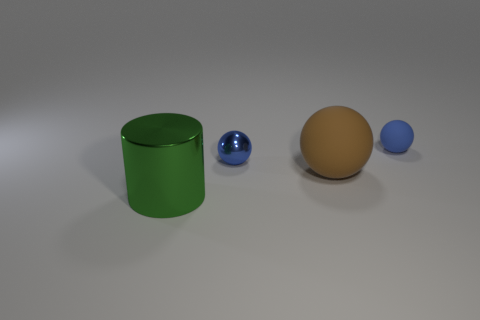Subtract all blue balls. How many balls are left? 1 Add 1 small blue rubber spheres. How many objects exist? 5 Subtract all brown balls. How many balls are left? 2 Add 1 yellow rubber cylinders. How many yellow rubber cylinders exist? 1 Subtract 0 green cubes. How many objects are left? 4 Subtract all cylinders. How many objects are left? 3 Subtract all cyan balls. Subtract all gray cylinders. How many balls are left? 3 Subtract all purple cylinders. How many blue balls are left? 2 Subtract all brown matte spheres. Subtract all metallic things. How many objects are left? 1 Add 4 large shiny objects. How many large shiny objects are left? 5 